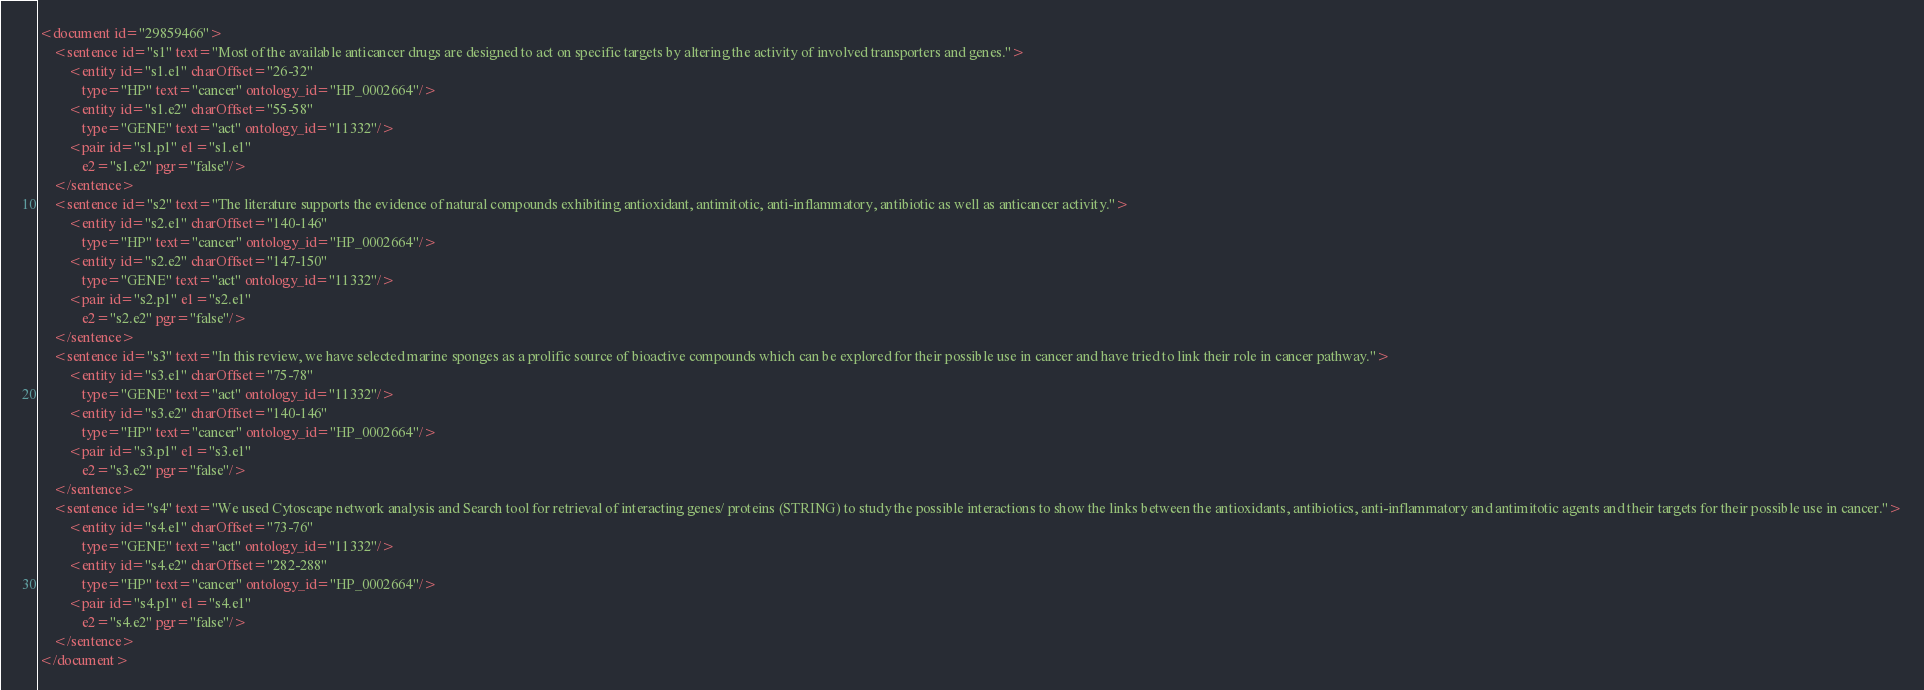<code> <loc_0><loc_0><loc_500><loc_500><_XML_><document id="29859466">
	<sentence id="s1" text="Most of the available anticancer drugs are designed to act on specific targets by altering the activity of involved transporters and genes.">
		<entity id="s1.e1" charOffset="26-32"
			type="HP" text="cancer" ontology_id="HP_0002664"/>
		<entity id="s1.e2" charOffset="55-58"
			type="GENE" text="act" ontology_id="11332"/>
		<pair id="s1.p1" e1="s1.e1"
		    e2="s1.e2" pgr="false"/>
	</sentence>
	<sentence id="s2" text="The literature supports the evidence of natural compounds exhibiting antioxidant, antimitotic, anti-inflammatory, antibiotic as well as anticancer activity.">
		<entity id="s2.e1" charOffset="140-146"
			type="HP" text="cancer" ontology_id="HP_0002664"/>
		<entity id="s2.e2" charOffset="147-150"
			type="GENE" text="act" ontology_id="11332"/>
		<pair id="s2.p1" e1="s2.e1"
		    e2="s2.e2" pgr="false"/>
	</sentence>
	<sentence id="s3" text="In this review, we have selected marine sponges as a prolific source of bioactive compounds which can be explored for their possible use in cancer and have tried to link their role in cancer pathway.">
		<entity id="s3.e1" charOffset="75-78"
			type="GENE" text="act" ontology_id="11332"/>
		<entity id="s3.e2" charOffset="140-146"
			type="HP" text="cancer" ontology_id="HP_0002664"/>
		<pair id="s3.p1" e1="s3.e1"
		    e2="s3.e2" pgr="false"/>
	</sentence>
	<sentence id="s4" text="We used Cytoscape network analysis and Search tool for retrieval of interacting genes/ proteins (STRING) to study the possible interactions to show the links between the antioxidants, antibiotics, anti-inflammatory and antimitotic agents and their targets for their possible use in cancer.">
		<entity id="s4.e1" charOffset="73-76"
			type="GENE" text="act" ontology_id="11332"/>
		<entity id="s4.e2" charOffset="282-288"
			type="HP" text="cancer" ontology_id="HP_0002664"/>
		<pair id="s4.p1" e1="s4.e1"
		    e2="s4.e2" pgr="false"/>
	</sentence>
</document>
</code> 